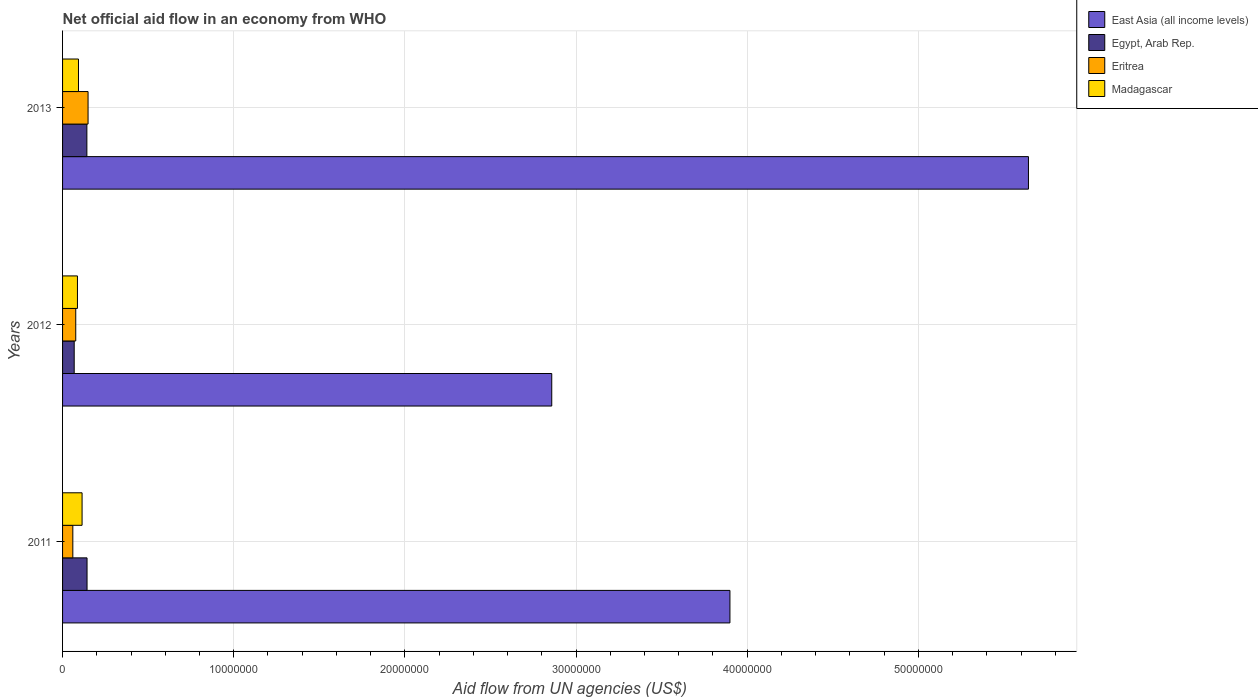How many groups of bars are there?
Provide a succinct answer. 3. How many bars are there on the 3rd tick from the top?
Keep it short and to the point. 4. What is the label of the 3rd group of bars from the top?
Make the answer very short. 2011. In how many cases, is the number of bars for a given year not equal to the number of legend labels?
Provide a short and direct response. 0. What is the net official aid flow in East Asia (all income levels) in 2013?
Offer a very short reply. 5.64e+07. Across all years, what is the maximum net official aid flow in Egypt, Arab Rep.?
Keep it short and to the point. 1.43e+06. Across all years, what is the minimum net official aid flow in Egypt, Arab Rep.?
Provide a succinct answer. 6.80e+05. In which year was the net official aid flow in East Asia (all income levels) maximum?
Offer a very short reply. 2013. What is the total net official aid flow in Eritrea in the graph?
Your answer should be compact. 2.86e+06. What is the difference between the net official aid flow in East Asia (all income levels) in 2011 and that in 2013?
Your answer should be very brief. -1.74e+07. What is the difference between the net official aid flow in Eritrea in 2011 and the net official aid flow in Madagascar in 2012?
Your answer should be very brief. -2.70e+05. What is the average net official aid flow in Egypt, Arab Rep. per year?
Make the answer very short. 1.18e+06. In the year 2011, what is the difference between the net official aid flow in Egypt, Arab Rep. and net official aid flow in East Asia (all income levels)?
Provide a short and direct response. -3.76e+07. What is the ratio of the net official aid flow in Egypt, Arab Rep. in 2011 to that in 2012?
Make the answer very short. 2.1. What is the difference between the highest and the second highest net official aid flow in East Asia (all income levels)?
Your response must be concise. 1.74e+07. What is the difference between the highest and the lowest net official aid flow in Eritrea?
Your answer should be very brief. 8.90e+05. Is the sum of the net official aid flow in Madagascar in 2011 and 2012 greater than the maximum net official aid flow in Eritrea across all years?
Your answer should be very brief. Yes. What does the 1st bar from the top in 2011 represents?
Provide a succinct answer. Madagascar. What does the 2nd bar from the bottom in 2012 represents?
Offer a terse response. Egypt, Arab Rep. How many years are there in the graph?
Make the answer very short. 3. What is the difference between two consecutive major ticks on the X-axis?
Offer a very short reply. 1.00e+07. Are the values on the major ticks of X-axis written in scientific E-notation?
Keep it short and to the point. No. Does the graph contain grids?
Your answer should be compact. Yes. How many legend labels are there?
Your response must be concise. 4. What is the title of the graph?
Provide a succinct answer. Net official aid flow in an economy from WHO. What is the label or title of the X-axis?
Make the answer very short. Aid flow from UN agencies (US$). What is the Aid flow from UN agencies (US$) of East Asia (all income levels) in 2011?
Provide a short and direct response. 3.90e+07. What is the Aid flow from UN agencies (US$) of Egypt, Arab Rep. in 2011?
Provide a succinct answer. 1.43e+06. What is the Aid flow from UN agencies (US$) of Madagascar in 2011?
Offer a terse response. 1.14e+06. What is the Aid flow from UN agencies (US$) in East Asia (all income levels) in 2012?
Provide a short and direct response. 2.86e+07. What is the Aid flow from UN agencies (US$) of Egypt, Arab Rep. in 2012?
Ensure brevity in your answer.  6.80e+05. What is the Aid flow from UN agencies (US$) of Eritrea in 2012?
Keep it short and to the point. 7.70e+05. What is the Aid flow from UN agencies (US$) of Madagascar in 2012?
Ensure brevity in your answer.  8.70e+05. What is the Aid flow from UN agencies (US$) of East Asia (all income levels) in 2013?
Offer a terse response. 5.64e+07. What is the Aid flow from UN agencies (US$) in Egypt, Arab Rep. in 2013?
Provide a succinct answer. 1.42e+06. What is the Aid flow from UN agencies (US$) of Eritrea in 2013?
Ensure brevity in your answer.  1.49e+06. What is the Aid flow from UN agencies (US$) in Madagascar in 2013?
Your answer should be very brief. 9.30e+05. Across all years, what is the maximum Aid flow from UN agencies (US$) in East Asia (all income levels)?
Your answer should be compact. 5.64e+07. Across all years, what is the maximum Aid flow from UN agencies (US$) in Egypt, Arab Rep.?
Keep it short and to the point. 1.43e+06. Across all years, what is the maximum Aid flow from UN agencies (US$) of Eritrea?
Offer a very short reply. 1.49e+06. Across all years, what is the maximum Aid flow from UN agencies (US$) of Madagascar?
Ensure brevity in your answer.  1.14e+06. Across all years, what is the minimum Aid flow from UN agencies (US$) in East Asia (all income levels)?
Give a very brief answer. 2.86e+07. Across all years, what is the minimum Aid flow from UN agencies (US$) of Egypt, Arab Rep.?
Make the answer very short. 6.80e+05. Across all years, what is the minimum Aid flow from UN agencies (US$) of Madagascar?
Offer a terse response. 8.70e+05. What is the total Aid flow from UN agencies (US$) of East Asia (all income levels) in the graph?
Offer a very short reply. 1.24e+08. What is the total Aid flow from UN agencies (US$) in Egypt, Arab Rep. in the graph?
Your answer should be compact. 3.53e+06. What is the total Aid flow from UN agencies (US$) of Eritrea in the graph?
Ensure brevity in your answer.  2.86e+06. What is the total Aid flow from UN agencies (US$) in Madagascar in the graph?
Offer a very short reply. 2.94e+06. What is the difference between the Aid flow from UN agencies (US$) of East Asia (all income levels) in 2011 and that in 2012?
Ensure brevity in your answer.  1.04e+07. What is the difference between the Aid flow from UN agencies (US$) in Egypt, Arab Rep. in 2011 and that in 2012?
Offer a terse response. 7.50e+05. What is the difference between the Aid flow from UN agencies (US$) in Eritrea in 2011 and that in 2012?
Provide a short and direct response. -1.70e+05. What is the difference between the Aid flow from UN agencies (US$) of East Asia (all income levels) in 2011 and that in 2013?
Keep it short and to the point. -1.74e+07. What is the difference between the Aid flow from UN agencies (US$) in Eritrea in 2011 and that in 2013?
Ensure brevity in your answer.  -8.90e+05. What is the difference between the Aid flow from UN agencies (US$) in Madagascar in 2011 and that in 2013?
Offer a very short reply. 2.10e+05. What is the difference between the Aid flow from UN agencies (US$) of East Asia (all income levels) in 2012 and that in 2013?
Make the answer very short. -2.78e+07. What is the difference between the Aid flow from UN agencies (US$) in Egypt, Arab Rep. in 2012 and that in 2013?
Provide a short and direct response. -7.40e+05. What is the difference between the Aid flow from UN agencies (US$) in Eritrea in 2012 and that in 2013?
Ensure brevity in your answer.  -7.20e+05. What is the difference between the Aid flow from UN agencies (US$) of East Asia (all income levels) in 2011 and the Aid flow from UN agencies (US$) of Egypt, Arab Rep. in 2012?
Keep it short and to the point. 3.83e+07. What is the difference between the Aid flow from UN agencies (US$) in East Asia (all income levels) in 2011 and the Aid flow from UN agencies (US$) in Eritrea in 2012?
Your answer should be compact. 3.82e+07. What is the difference between the Aid flow from UN agencies (US$) in East Asia (all income levels) in 2011 and the Aid flow from UN agencies (US$) in Madagascar in 2012?
Make the answer very short. 3.81e+07. What is the difference between the Aid flow from UN agencies (US$) of Egypt, Arab Rep. in 2011 and the Aid flow from UN agencies (US$) of Eritrea in 2012?
Offer a terse response. 6.60e+05. What is the difference between the Aid flow from UN agencies (US$) of Egypt, Arab Rep. in 2011 and the Aid flow from UN agencies (US$) of Madagascar in 2012?
Your answer should be compact. 5.60e+05. What is the difference between the Aid flow from UN agencies (US$) in Eritrea in 2011 and the Aid flow from UN agencies (US$) in Madagascar in 2012?
Offer a very short reply. -2.70e+05. What is the difference between the Aid flow from UN agencies (US$) of East Asia (all income levels) in 2011 and the Aid flow from UN agencies (US$) of Egypt, Arab Rep. in 2013?
Give a very brief answer. 3.76e+07. What is the difference between the Aid flow from UN agencies (US$) of East Asia (all income levels) in 2011 and the Aid flow from UN agencies (US$) of Eritrea in 2013?
Give a very brief answer. 3.75e+07. What is the difference between the Aid flow from UN agencies (US$) in East Asia (all income levels) in 2011 and the Aid flow from UN agencies (US$) in Madagascar in 2013?
Ensure brevity in your answer.  3.81e+07. What is the difference between the Aid flow from UN agencies (US$) of Eritrea in 2011 and the Aid flow from UN agencies (US$) of Madagascar in 2013?
Offer a terse response. -3.30e+05. What is the difference between the Aid flow from UN agencies (US$) of East Asia (all income levels) in 2012 and the Aid flow from UN agencies (US$) of Egypt, Arab Rep. in 2013?
Provide a short and direct response. 2.72e+07. What is the difference between the Aid flow from UN agencies (US$) of East Asia (all income levels) in 2012 and the Aid flow from UN agencies (US$) of Eritrea in 2013?
Ensure brevity in your answer.  2.71e+07. What is the difference between the Aid flow from UN agencies (US$) in East Asia (all income levels) in 2012 and the Aid flow from UN agencies (US$) in Madagascar in 2013?
Offer a very short reply. 2.76e+07. What is the difference between the Aid flow from UN agencies (US$) in Egypt, Arab Rep. in 2012 and the Aid flow from UN agencies (US$) in Eritrea in 2013?
Make the answer very short. -8.10e+05. What is the average Aid flow from UN agencies (US$) in East Asia (all income levels) per year?
Keep it short and to the point. 4.13e+07. What is the average Aid flow from UN agencies (US$) of Egypt, Arab Rep. per year?
Ensure brevity in your answer.  1.18e+06. What is the average Aid flow from UN agencies (US$) in Eritrea per year?
Your response must be concise. 9.53e+05. What is the average Aid flow from UN agencies (US$) of Madagascar per year?
Keep it short and to the point. 9.80e+05. In the year 2011, what is the difference between the Aid flow from UN agencies (US$) in East Asia (all income levels) and Aid flow from UN agencies (US$) in Egypt, Arab Rep.?
Offer a very short reply. 3.76e+07. In the year 2011, what is the difference between the Aid flow from UN agencies (US$) in East Asia (all income levels) and Aid flow from UN agencies (US$) in Eritrea?
Your answer should be compact. 3.84e+07. In the year 2011, what is the difference between the Aid flow from UN agencies (US$) in East Asia (all income levels) and Aid flow from UN agencies (US$) in Madagascar?
Offer a terse response. 3.78e+07. In the year 2011, what is the difference between the Aid flow from UN agencies (US$) in Egypt, Arab Rep. and Aid flow from UN agencies (US$) in Eritrea?
Provide a succinct answer. 8.30e+05. In the year 2011, what is the difference between the Aid flow from UN agencies (US$) in Eritrea and Aid flow from UN agencies (US$) in Madagascar?
Your response must be concise. -5.40e+05. In the year 2012, what is the difference between the Aid flow from UN agencies (US$) of East Asia (all income levels) and Aid flow from UN agencies (US$) of Egypt, Arab Rep.?
Offer a very short reply. 2.79e+07. In the year 2012, what is the difference between the Aid flow from UN agencies (US$) of East Asia (all income levels) and Aid flow from UN agencies (US$) of Eritrea?
Provide a succinct answer. 2.78e+07. In the year 2012, what is the difference between the Aid flow from UN agencies (US$) in East Asia (all income levels) and Aid flow from UN agencies (US$) in Madagascar?
Provide a short and direct response. 2.77e+07. In the year 2012, what is the difference between the Aid flow from UN agencies (US$) of Egypt, Arab Rep. and Aid flow from UN agencies (US$) of Eritrea?
Give a very brief answer. -9.00e+04. In the year 2013, what is the difference between the Aid flow from UN agencies (US$) of East Asia (all income levels) and Aid flow from UN agencies (US$) of Egypt, Arab Rep.?
Offer a very short reply. 5.50e+07. In the year 2013, what is the difference between the Aid flow from UN agencies (US$) of East Asia (all income levels) and Aid flow from UN agencies (US$) of Eritrea?
Your answer should be very brief. 5.49e+07. In the year 2013, what is the difference between the Aid flow from UN agencies (US$) of East Asia (all income levels) and Aid flow from UN agencies (US$) of Madagascar?
Your response must be concise. 5.55e+07. In the year 2013, what is the difference between the Aid flow from UN agencies (US$) of Egypt, Arab Rep. and Aid flow from UN agencies (US$) of Eritrea?
Offer a terse response. -7.00e+04. In the year 2013, what is the difference between the Aid flow from UN agencies (US$) of Eritrea and Aid flow from UN agencies (US$) of Madagascar?
Provide a short and direct response. 5.60e+05. What is the ratio of the Aid flow from UN agencies (US$) in East Asia (all income levels) in 2011 to that in 2012?
Your answer should be very brief. 1.36. What is the ratio of the Aid flow from UN agencies (US$) in Egypt, Arab Rep. in 2011 to that in 2012?
Your answer should be compact. 2.1. What is the ratio of the Aid flow from UN agencies (US$) in Eritrea in 2011 to that in 2012?
Your answer should be compact. 0.78. What is the ratio of the Aid flow from UN agencies (US$) of Madagascar in 2011 to that in 2012?
Offer a terse response. 1.31. What is the ratio of the Aid flow from UN agencies (US$) of East Asia (all income levels) in 2011 to that in 2013?
Make the answer very short. 0.69. What is the ratio of the Aid flow from UN agencies (US$) of Eritrea in 2011 to that in 2013?
Ensure brevity in your answer.  0.4. What is the ratio of the Aid flow from UN agencies (US$) of Madagascar in 2011 to that in 2013?
Your answer should be very brief. 1.23. What is the ratio of the Aid flow from UN agencies (US$) of East Asia (all income levels) in 2012 to that in 2013?
Your response must be concise. 0.51. What is the ratio of the Aid flow from UN agencies (US$) of Egypt, Arab Rep. in 2012 to that in 2013?
Give a very brief answer. 0.48. What is the ratio of the Aid flow from UN agencies (US$) of Eritrea in 2012 to that in 2013?
Your answer should be very brief. 0.52. What is the ratio of the Aid flow from UN agencies (US$) in Madagascar in 2012 to that in 2013?
Provide a short and direct response. 0.94. What is the difference between the highest and the second highest Aid flow from UN agencies (US$) of East Asia (all income levels)?
Your response must be concise. 1.74e+07. What is the difference between the highest and the second highest Aid flow from UN agencies (US$) in Egypt, Arab Rep.?
Your response must be concise. 10000. What is the difference between the highest and the second highest Aid flow from UN agencies (US$) of Eritrea?
Offer a terse response. 7.20e+05. What is the difference between the highest and the lowest Aid flow from UN agencies (US$) in East Asia (all income levels)?
Your answer should be very brief. 2.78e+07. What is the difference between the highest and the lowest Aid flow from UN agencies (US$) of Egypt, Arab Rep.?
Provide a succinct answer. 7.50e+05. What is the difference between the highest and the lowest Aid flow from UN agencies (US$) of Eritrea?
Your answer should be very brief. 8.90e+05. What is the difference between the highest and the lowest Aid flow from UN agencies (US$) in Madagascar?
Keep it short and to the point. 2.70e+05. 